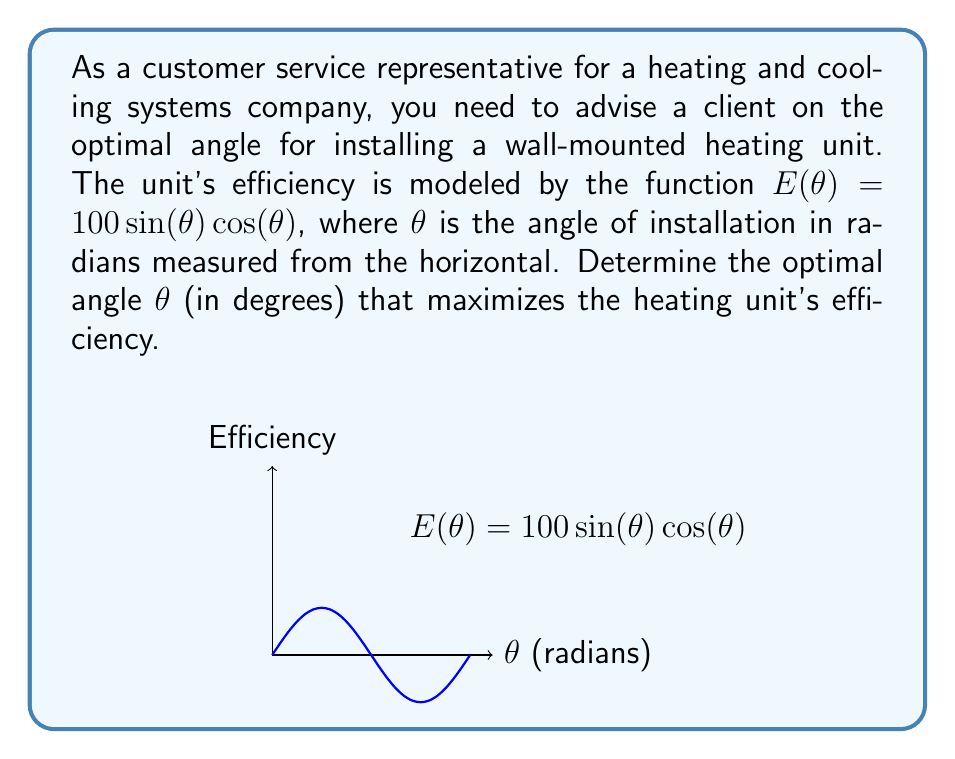What is the answer to this math problem? To find the optimal angle, we need to maximize the efficiency function $E(\theta) = 100\sin(\theta)\cos(\theta)$.

1) First, we can simplify this function using the trigonometric identity $\sin(2\theta) = 2\sin(\theta)\cos(\theta)$:

   $E(\theta) = 100\sin(\theta)\cos(\theta) = 50\sin(2\theta)$

2) To find the maximum, we need to find where the derivative of $E(\theta)$ equals zero:

   $\frac{dE}{d\theta} = 100\cos(2\theta)$

3) Set this equal to zero and solve:

   $100\cos(2\theta) = 0$
   $\cos(2\theta) = 0$

4) The cosine function equals zero when its argument is $\frac{\pi}{2}$ or $\frac{3\pi}{2}$. So:

   $2\theta = \frac{\pi}{2}$ or $2\theta = \frac{3\pi}{2}$
   $\theta = \frac{\pi}{4}$ or $\theta = \frac{3\pi}{4}$

5) To determine which of these is the maximum (rather than the minimum), we can check the second derivative or simply evaluate $E(\theta)$ at both points. $E(\frac{\pi}{4}) = 50$ and $E(\frac{3\pi}{4}) = -50$, so $\frac{\pi}{4}$ gives the maximum.

6) Convert $\frac{\pi}{4}$ radians to degrees:

   $\frac{\pi}{4} \cdot \frac{180°}{\pi} = 45°$

Therefore, the optimal angle for installing the heating unit is 45° from the horizontal.
Answer: 45° 